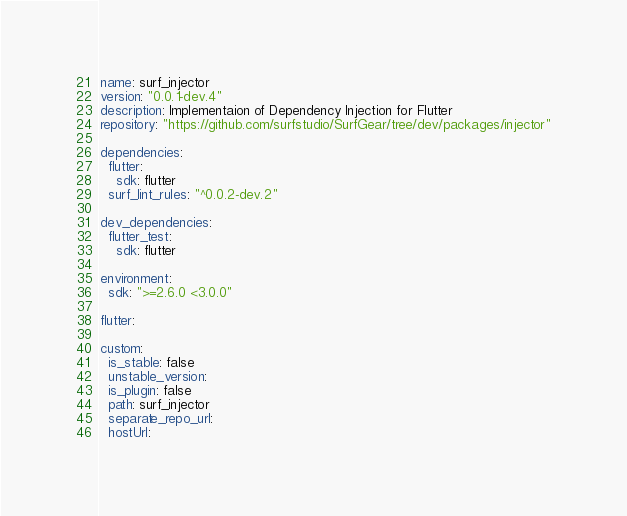Convert code to text. <code><loc_0><loc_0><loc_500><loc_500><_YAML_>name: surf_injector
version: "0.0.1-dev.4"
description: Implementaion of Dependency Injection for Flutter
repository: "https://github.com/surfstudio/SurfGear/tree/dev/packages/injector"

dependencies:
  flutter:
    sdk: flutter
  surf_lint_rules: "^0.0.2-dev.2"

dev_dependencies:
  flutter_test:
    sdk: flutter

environment:
  sdk: ">=2.6.0 <3.0.0"

flutter:

custom:
  is_stable: false
  unstable_version:
  is_plugin: false
  path: surf_injector
  separate_repo_url:
  hostUrl:
</code> 